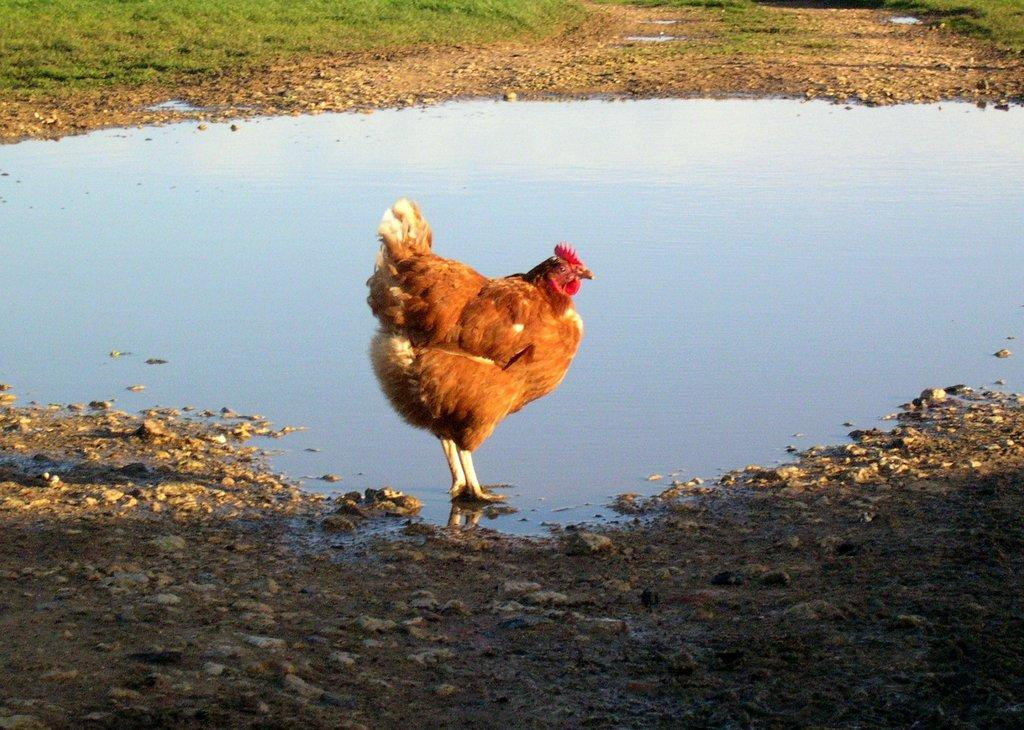What type of animal is in the image? There is a hen in the image. Can you describe the coloring of the hen? The hen has white, brown, and red coloring. What can be seen in the background of the image? There is water visible in the image. What is the surface beneath the hen? There is ground in the image. What type of objects are on the ground? There are stones on the ground. What type of vegetation is present in the image? There is green grass in the image. What type of camera is visible in the image? There is no camera present in the image. Is there an arch visible in the image? There is no arch present in the image. 